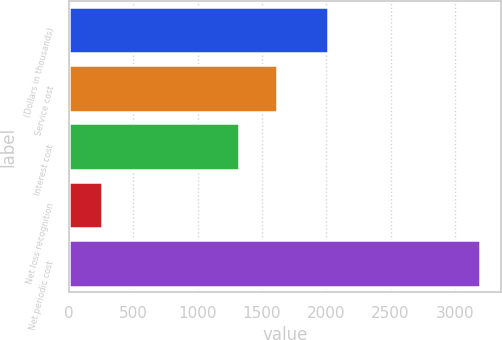Convert chart to OTSL. <chart><loc_0><loc_0><loc_500><loc_500><bar_chart><fcel>(Dollars in thousands)<fcel>Service cost<fcel>Interest cost<fcel>Net loss recognition<fcel>Net periodic cost<nl><fcel>2014<fcel>1619<fcel>1320<fcel>257<fcel>3196<nl></chart> 